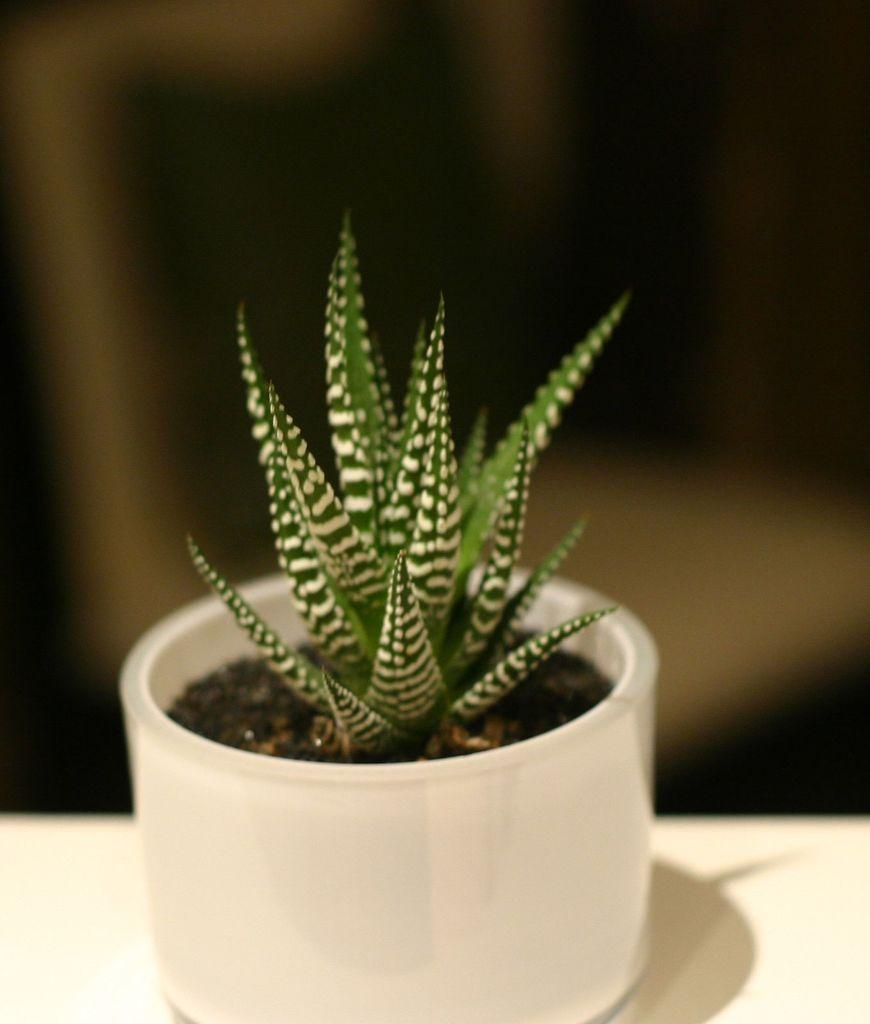What type of living organism is in the image? There is a plant in the image. What is the color of the pot in which the plant is placed? The pot is white. Where is the pot with the plant located? The pot is kept on a wall. How many socks are hanging on the wall next to the plant? There are no socks present in the image; it only features a plant in a white pot on a wall. 